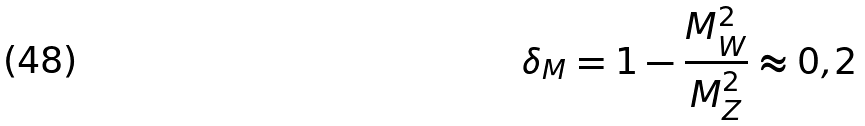Convert formula to latex. <formula><loc_0><loc_0><loc_500><loc_500>\delta _ { M } = 1 - \frac { M _ { W } ^ { 2 } } { M _ { Z } ^ { 2 } } \approx 0 { , } 2</formula> 